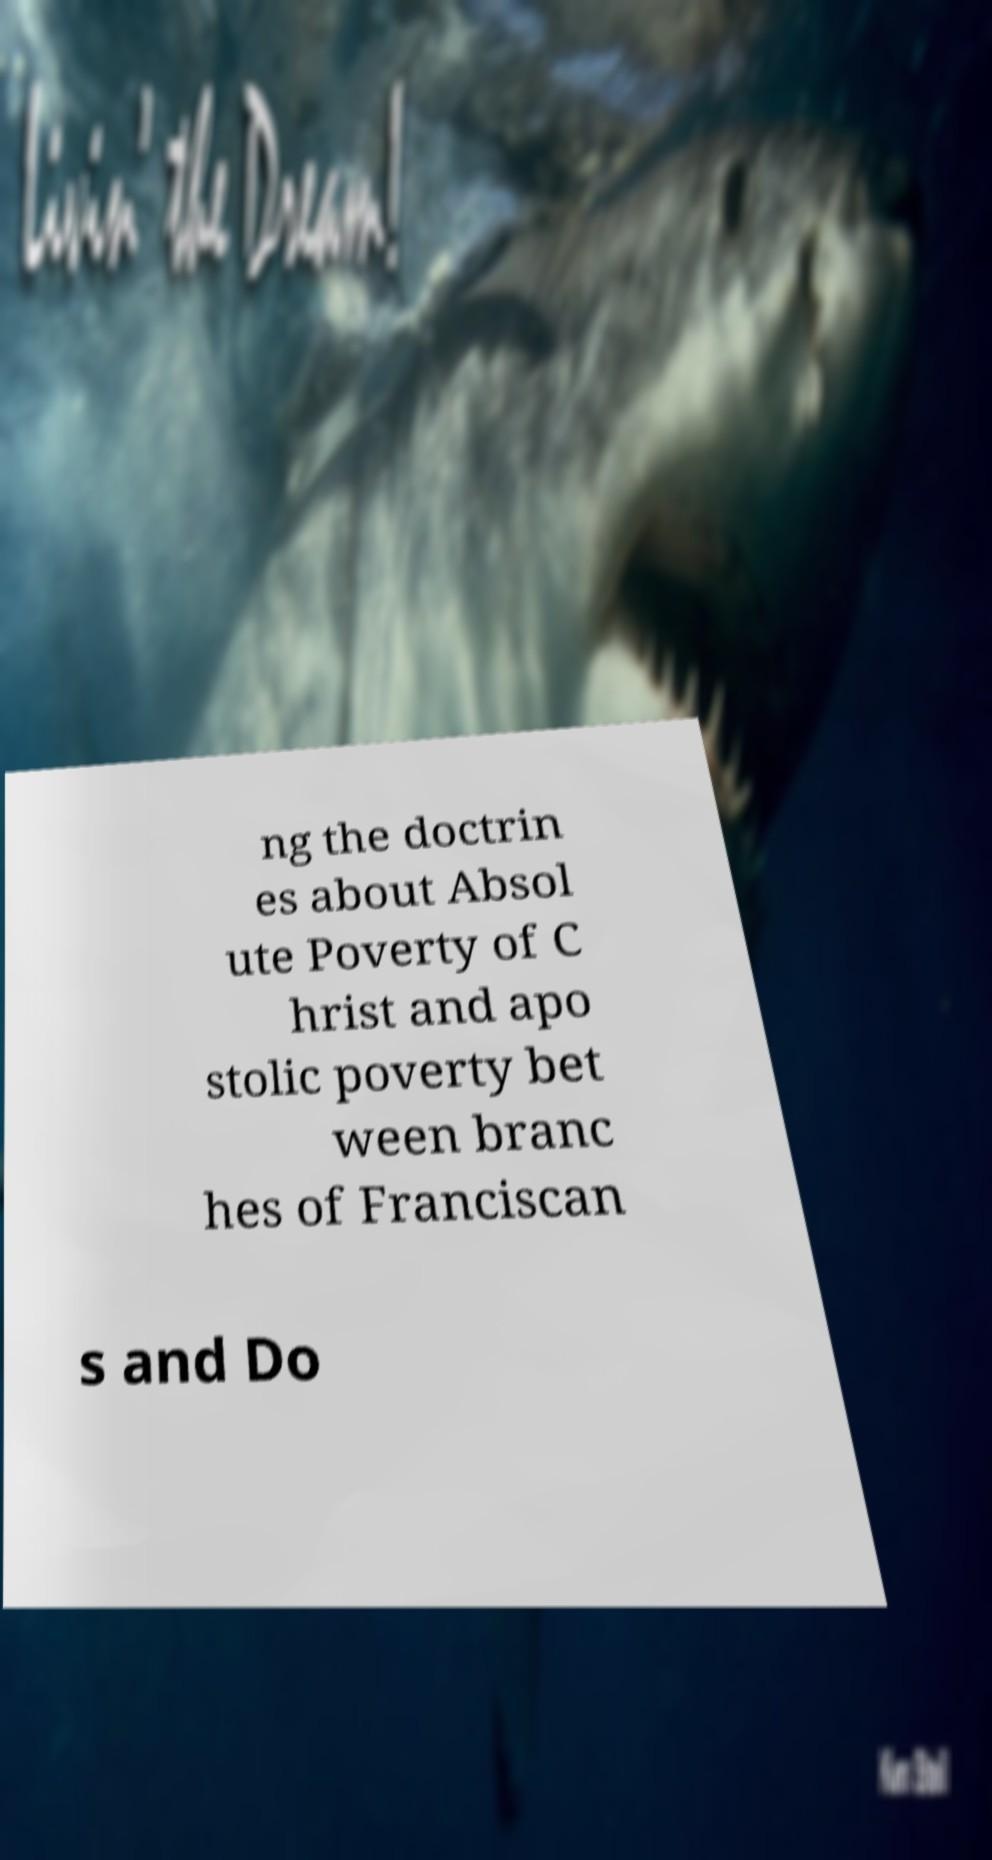What messages or text are displayed in this image? I need them in a readable, typed format. ng the doctrin es about Absol ute Poverty of C hrist and apo stolic poverty bet ween branc hes of Franciscan s and Do 